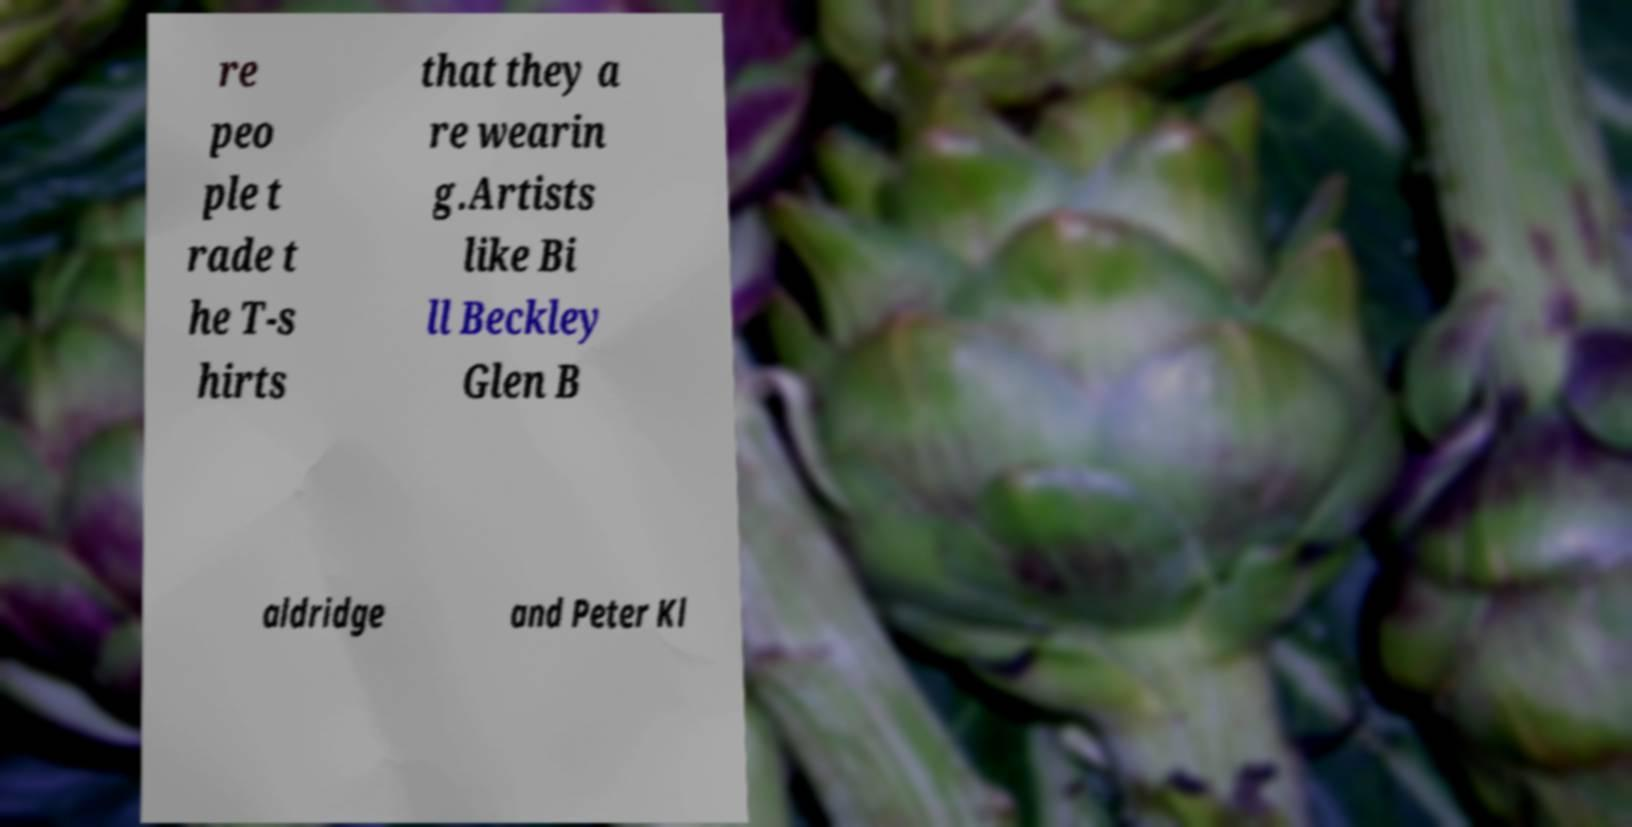I need the written content from this picture converted into text. Can you do that? re peo ple t rade t he T-s hirts that they a re wearin g.Artists like Bi ll Beckley Glen B aldridge and Peter Kl 